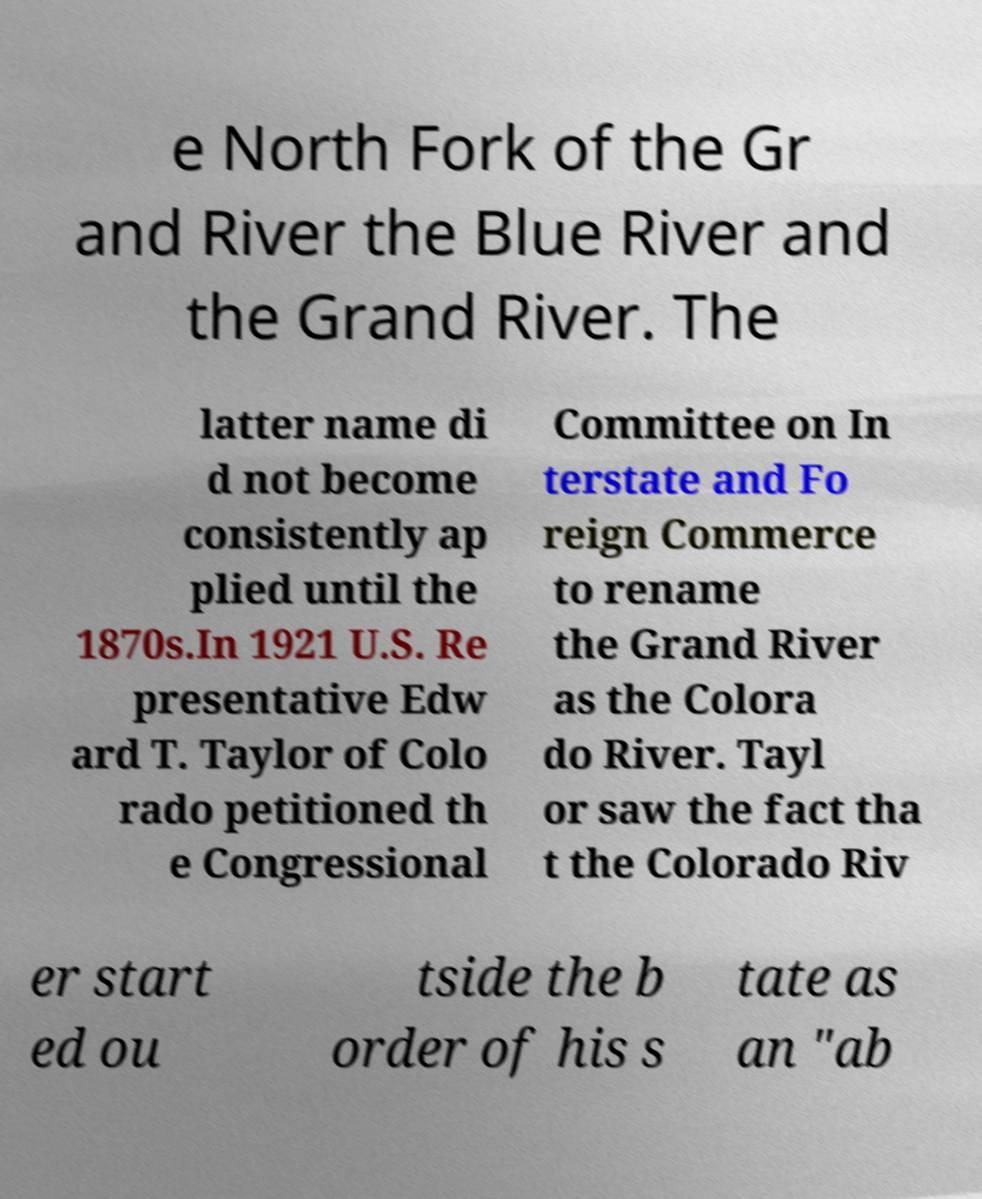Can you accurately transcribe the text from the provided image for me? e North Fork of the Gr and River the Blue River and the Grand River. The latter name di d not become consistently ap plied until the 1870s.In 1921 U.S. Re presentative Edw ard T. Taylor of Colo rado petitioned th e Congressional Committee on In terstate and Fo reign Commerce to rename the Grand River as the Colora do River. Tayl or saw the fact tha t the Colorado Riv er start ed ou tside the b order of his s tate as an "ab 